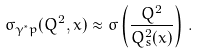Convert formula to latex. <formula><loc_0><loc_0><loc_500><loc_500>\sigma _ { \gamma ^ { * } p } ( Q ^ { 2 } , x ) \approx \sigma \left ( \frac { Q ^ { 2 } } { Q _ { s } ^ { 2 } ( x ) } \right ) \, .</formula> 